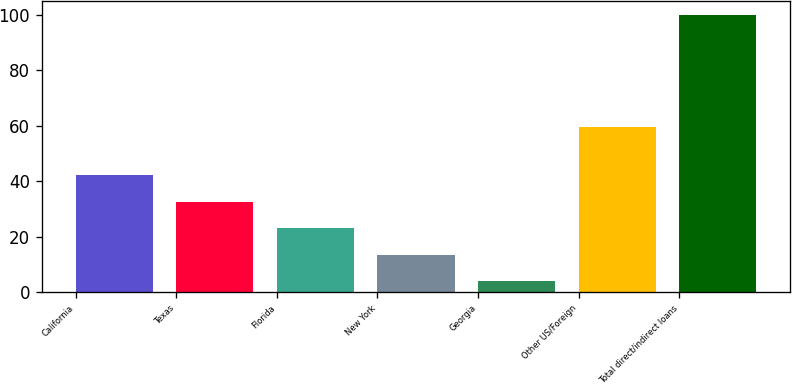Convert chart to OTSL. <chart><loc_0><loc_0><loc_500><loc_500><bar_chart><fcel>California<fcel>Texas<fcel>Florida<fcel>New York<fcel>Georgia<fcel>Other US/Foreign<fcel>Total direct/indirect loans<nl><fcel>42.28<fcel>32.66<fcel>23.04<fcel>13.42<fcel>3.8<fcel>59.5<fcel>100<nl></chart> 